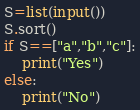Convert code to text. <code><loc_0><loc_0><loc_500><loc_500><_Python_>S=list(input())
S.sort()
if S==["a","b","c"]:
    print("Yes")
else:
    print("No")</code> 